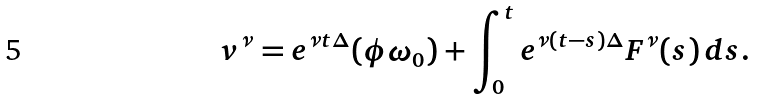<formula> <loc_0><loc_0><loc_500><loc_500>v ^ { \nu } = e ^ { \nu t \Delta } ( \phi \omega _ { 0 } ) + \int _ { 0 } ^ { t } e ^ { \nu ( t - s ) \Delta } F ^ { \nu } ( s ) \, d s .</formula> 